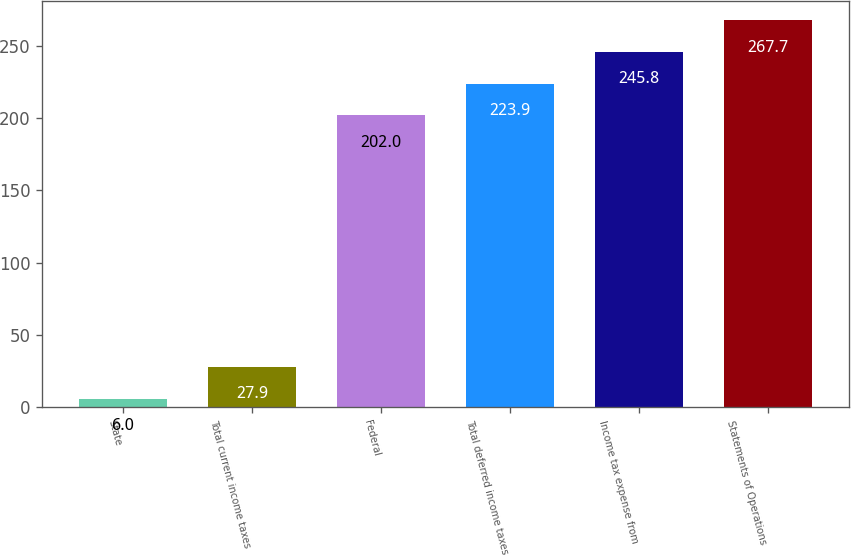Convert chart. <chart><loc_0><loc_0><loc_500><loc_500><bar_chart><fcel>State<fcel>Total current income taxes<fcel>Federal<fcel>Total deferred income taxes<fcel>Income tax expense from<fcel>Statements of Operations<nl><fcel>6<fcel>27.9<fcel>202<fcel>223.9<fcel>245.8<fcel>267.7<nl></chart> 